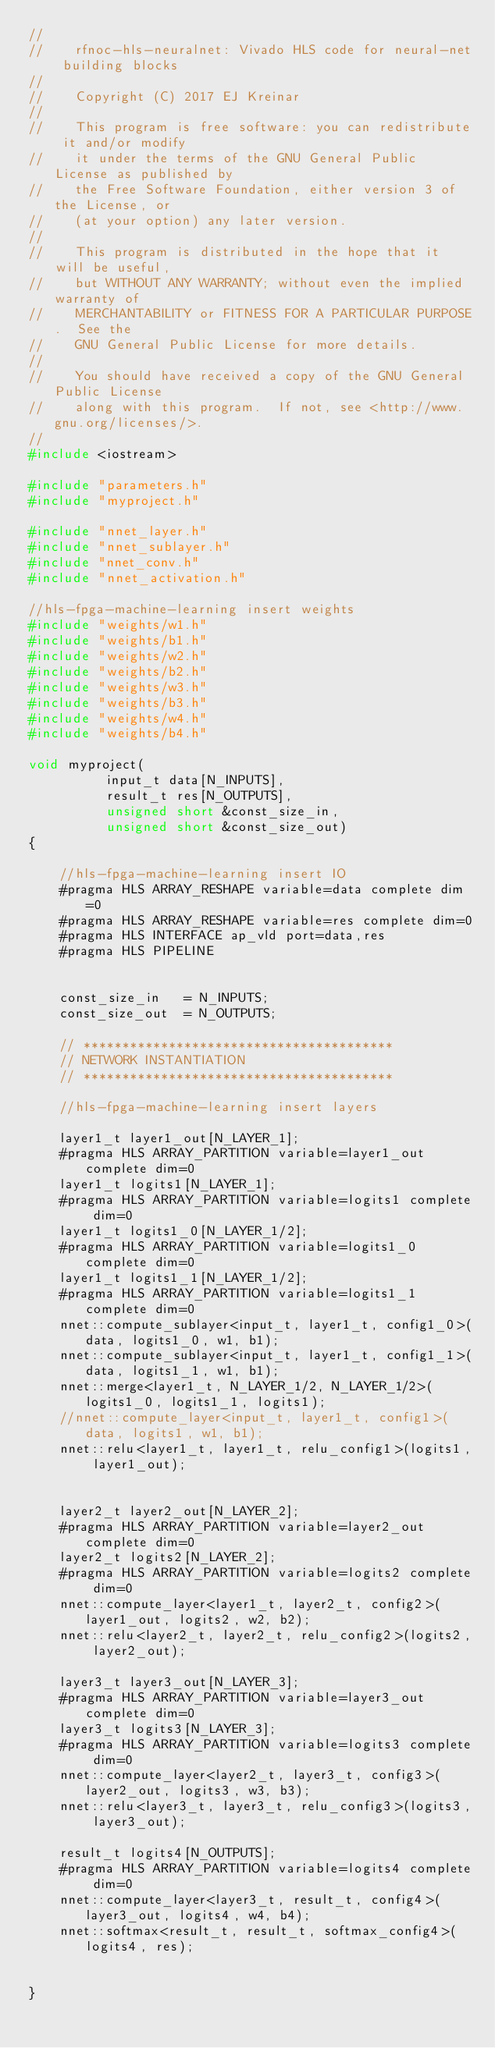Convert code to text. <code><loc_0><loc_0><loc_500><loc_500><_C++_>//
//    rfnoc-hls-neuralnet: Vivado HLS code for neural-net building blocks
//
//    Copyright (C) 2017 EJ Kreinar
//
//    This program is free software: you can redistribute it and/or modify
//    it under the terms of the GNU General Public License as published by
//    the Free Software Foundation, either version 3 of the License, or
//    (at your option) any later version.
//
//    This program is distributed in the hope that it will be useful,
//    but WITHOUT ANY WARRANTY; without even the implied warranty of
//    MERCHANTABILITY or FITNESS FOR A PARTICULAR PURPOSE.  See the
//    GNU General Public License for more details.
//
//    You should have received a copy of the GNU General Public License
//    along with this program.  If not, see <http://www.gnu.org/licenses/>.
//
#include <iostream>

#include "parameters.h"
#include "myproject.h"

#include "nnet_layer.h"
#include "nnet_sublayer.h"
#include "nnet_conv.h"
#include "nnet_activation.h"

//hls-fpga-machine-learning insert weights
#include "weights/w1.h"
#include "weights/b1.h"
#include "weights/w2.h"
#include "weights/b2.h"
#include "weights/w3.h"
#include "weights/b3.h"
#include "weights/w4.h"
#include "weights/b4.h"

void myproject(
		  input_t data[N_INPUTS],
		  result_t res[N_OUTPUTS],
		  unsigned short &const_size_in,
		  unsigned short &const_size_out)
{

    //hls-fpga-machine-learning insert IO
    #pragma HLS ARRAY_RESHAPE variable=data complete dim=0 
    #pragma HLS ARRAY_RESHAPE variable=res complete dim=0 
    #pragma HLS INTERFACE ap_vld port=data,res 
    #pragma HLS PIPELINE 


    const_size_in   = N_INPUTS;
    const_size_out  = N_OUTPUTS;

    // ****************************************
    // NETWORK INSTANTIATION
    // ****************************************

    //hls-fpga-machine-learning insert layers

    layer1_t layer1_out[N_LAYER_1];
    #pragma HLS ARRAY_PARTITION variable=layer1_out complete dim=0
    layer1_t logits1[N_LAYER_1];
    #pragma HLS ARRAY_PARTITION variable=logits1 complete dim=0
    layer1_t logits1_0[N_LAYER_1/2];
    #pragma HLS ARRAY_PARTITION variable=logits1_0 complete dim=0
    layer1_t logits1_1[N_LAYER_1/2];
    #pragma HLS ARRAY_PARTITION variable=logits1_1 complete dim=0
    nnet::compute_sublayer<input_t, layer1_t, config1_0>(data, logits1_0, w1, b1);
    nnet::compute_sublayer<input_t, layer1_t, config1_1>(data, logits1_1, w1, b1);
    nnet::merge<layer1_t, N_LAYER_1/2, N_LAYER_1/2>(logits1_0, logits1_1, logits1);
    //nnet::compute_layer<input_t, layer1_t, config1>(data, logits1, w1, b1);
    nnet::relu<layer1_t, layer1_t, relu_config1>(logits1, layer1_out);


    layer2_t layer2_out[N_LAYER_2];
    #pragma HLS ARRAY_PARTITION variable=layer2_out complete dim=0
    layer2_t logits2[N_LAYER_2];
    #pragma HLS ARRAY_PARTITION variable=logits2 complete dim=0
    nnet::compute_layer<layer1_t, layer2_t, config2>(layer1_out, logits2, w2, b2);
    nnet::relu<layer2_t, layer2_t, relu_config2>(logits2, layer2_out);

    layer3_t layer3_out[N_LAYER_3];
    #pragma HLS ARRAY_PARTITION variable=layer3_out complete dim=0
    layer3_t logits3[N_LAYER_3];
    #pragma HLS ARRAY_PARTITION variable=logits3 complete dim=0
    nnet::compute_layer<layer2_t, layer3_t, config3>(layer2_out, logits3, w3, b3);
    nnet::relu<layer3_t, layer3_t, relu_config3>(logits3, layer3_out);

    result_t logits4[N_OUTPUTS];
    #pragma HLS ARRAY_PARTITION variable=logits4 complete dim=0
    nnet::compute_layer<layer3_t, result_t, config4>(layer3_out, logits4, w4, b4);
    nnet::softmax<result_t, result_t, softmax_config4>(logits4, res);


}
</code> 